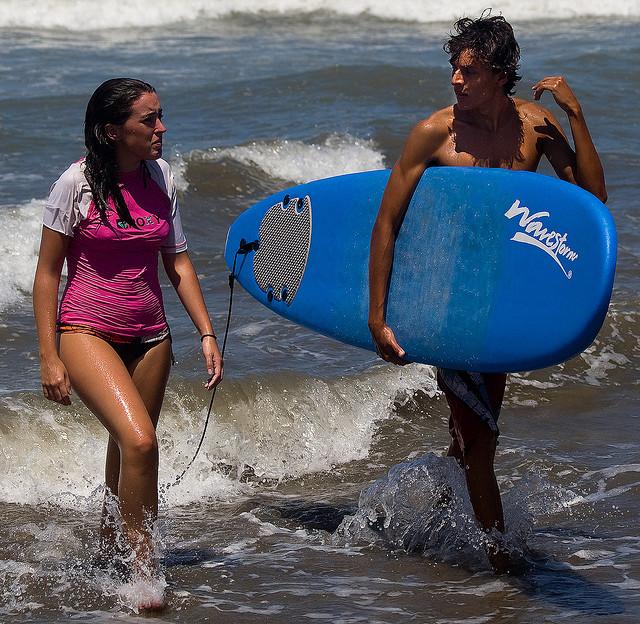Are there people in the water?
Write a very short answer. Yes. Is the woman happy?
Give a very brief answer. No. How many females in this photo?
Write a very short answer. 1. 